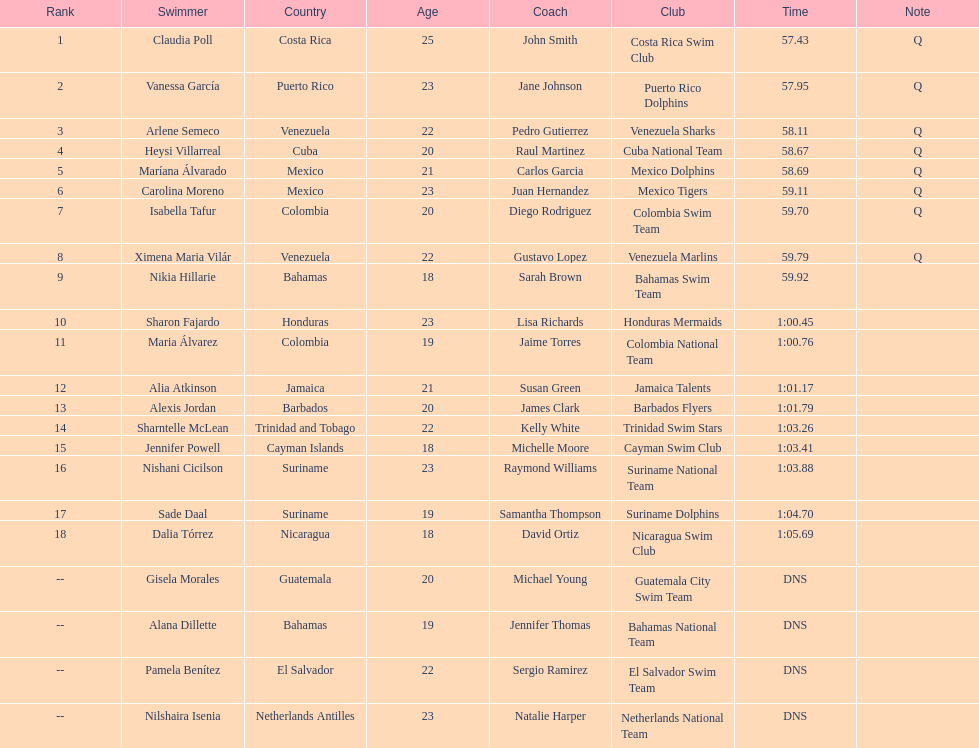How many swimmers did not swim? 4. 